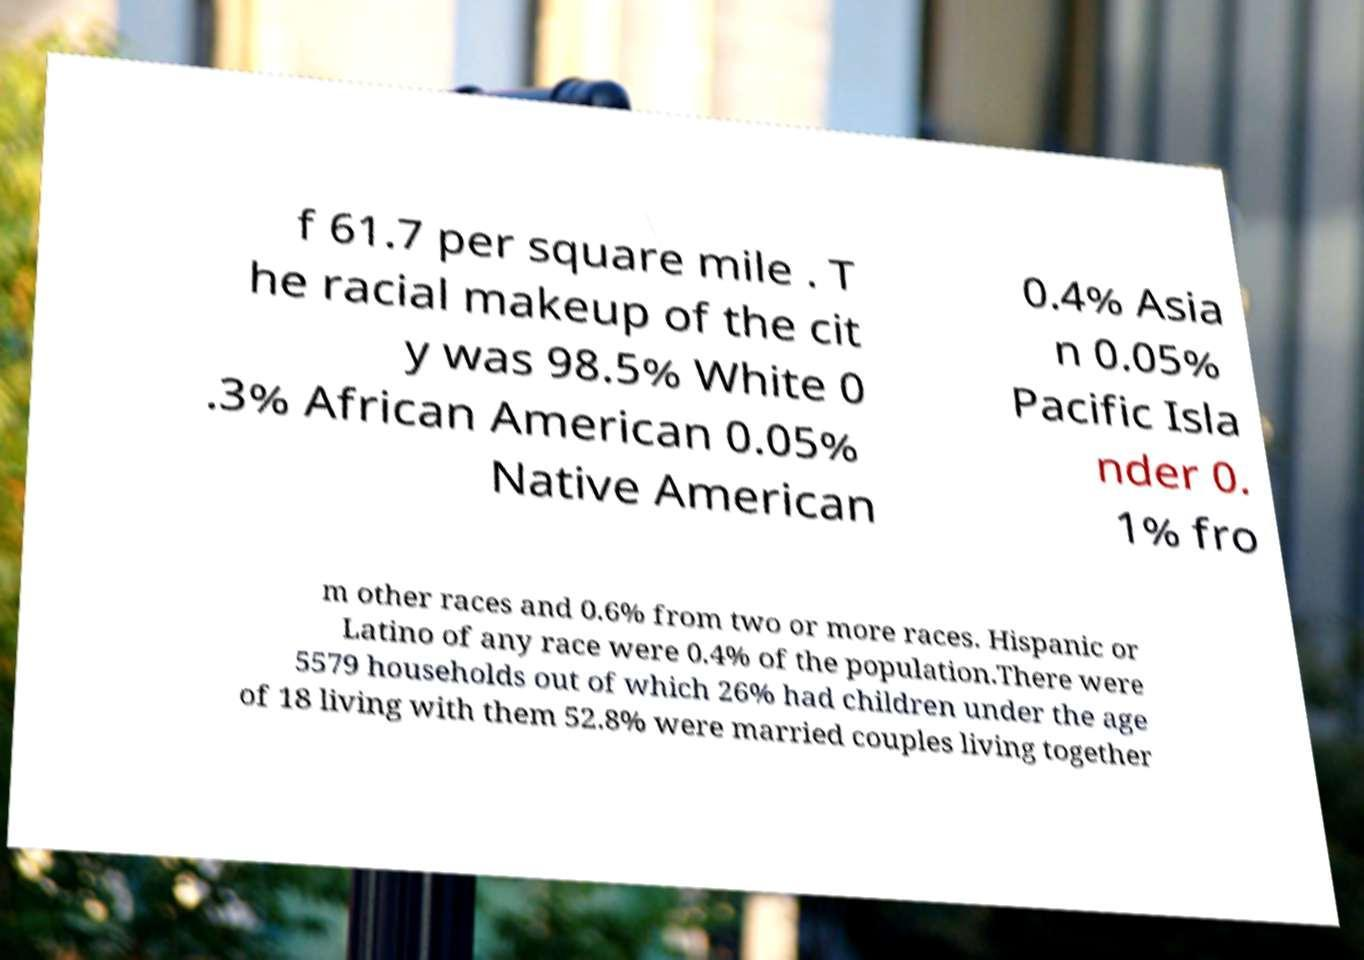For documentation purposes, I need the text within this image transcribed. Could you provide that? f 61.7 per square mile . T he racial makeup of the cit y was 98.5% White 0 .3% African American 0.05% Native American 0.4% Asia n 0.05% Pacific Isla nder 0. 1% fro m other races and 0.6% from two or more races. Hispanic or Latino of any race were 0.4% of the population.There were 5579 households out of which 26% had children under the age of 18 living with them 52.8% were married couples living together 